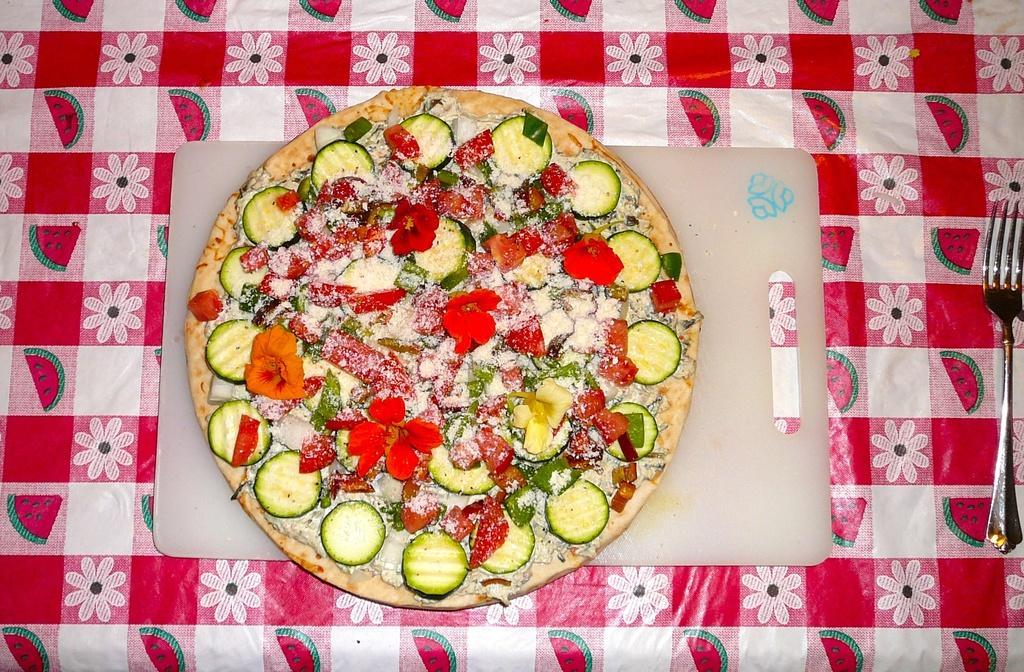What is the main subject on the cutting table in the image? There is a food item on a cutting table in the image. What utensil is located on the right side of the table? There is a fork on the right side of the table. What covers the table in the image? There is a tablecloth on the table. Can you see any plants or a lake in the image? No, there are no plants or a lake visible in the image. 